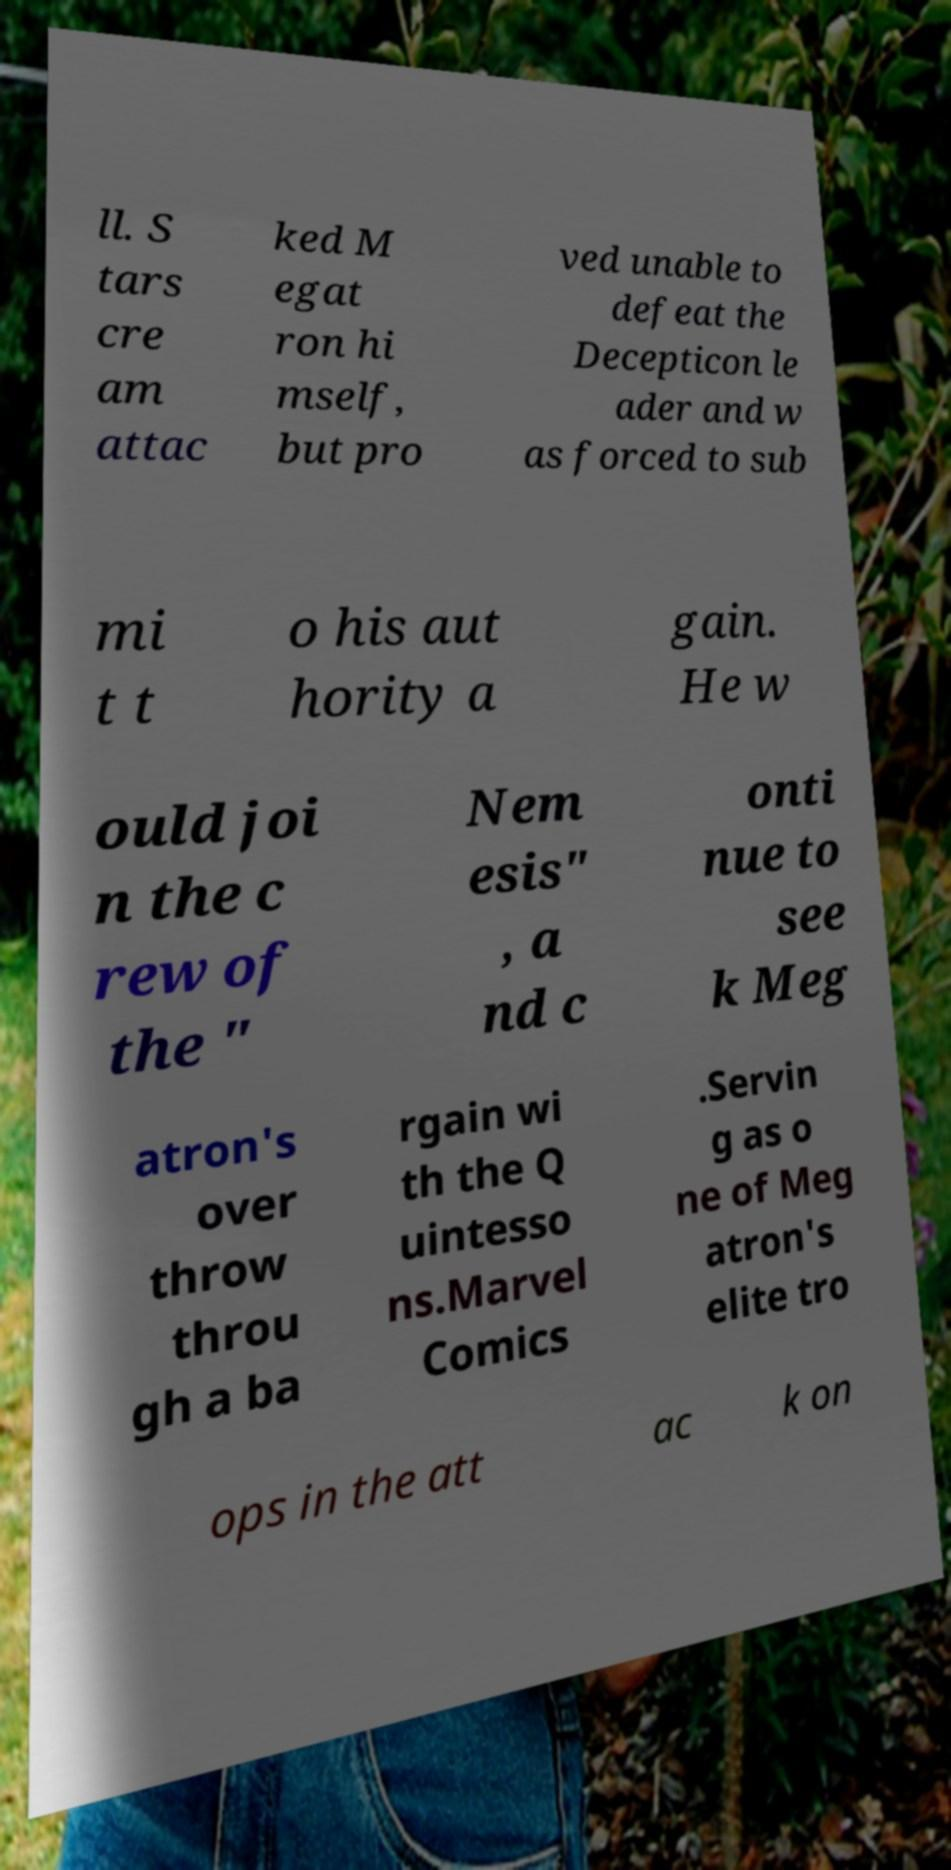There's text embedded in this image that I need extracted. Can you transcribe it verbatim? ll. S tars cre am attac ked M egat ron hi mself, but pro ved unable to defeat the Decepticon le ader and w as forced to sub mi t t o his aut hority a gain. He w ould joi n the c rew of the " Nem esis" , a nd c onti nue to see k Meg atron's over throw throu gh a ba rgain wi th the Q uintesso ns.Marvel Comics .Servin g as o ne of Meg atron's elite tro ops in the att ac k on 